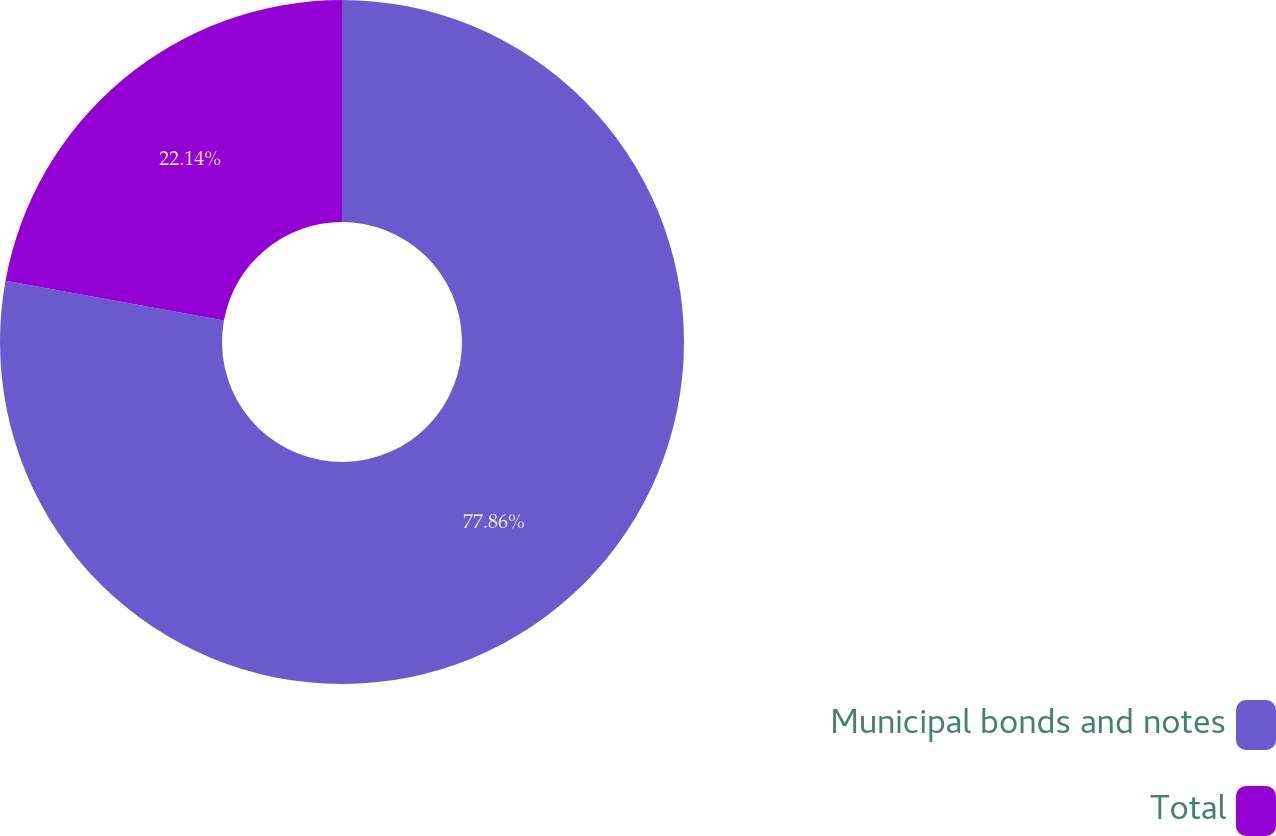<chart> <loc_0><loc_0><loc_500><loc_500><pie_chart><fcel>Municipal bonds and notes<fcel>Total<nl><fcel>77.86%<fcel>22.14%<nl></chart> 